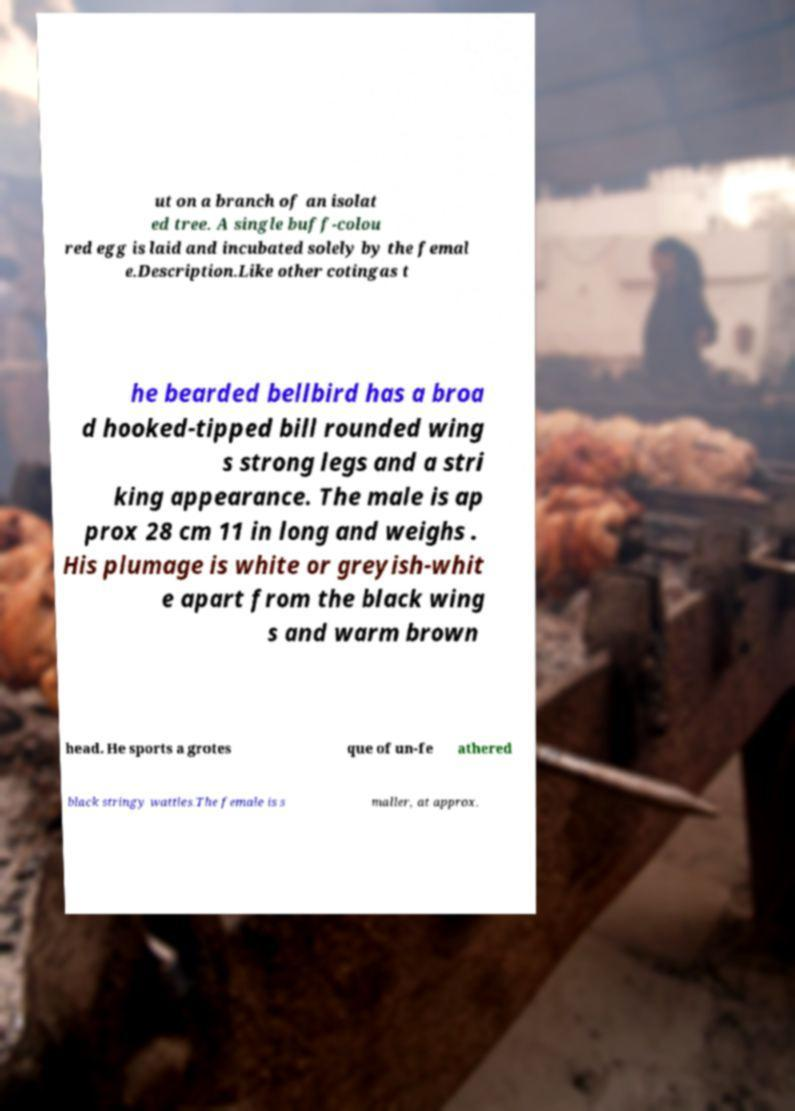What messages or text are displayed in this image? I need them in a readable, typed format. ut on a branch of an isolat ed tree. A single buff-colou red egg is laid and incubated solely by the femal e.Description.Like other cotingas t he bearded bellbird has a broa d hooked-tipped bill rounded wing s strong legs and a stri king appearance. The male is ap prox 28 cm 11 in long and weighs . His plumage is white or greyish-whit e apart from the black wing s and warm brown head. He sports a grotes que of un-fe athered black stringy wattles.The female is s maller, at approx. 